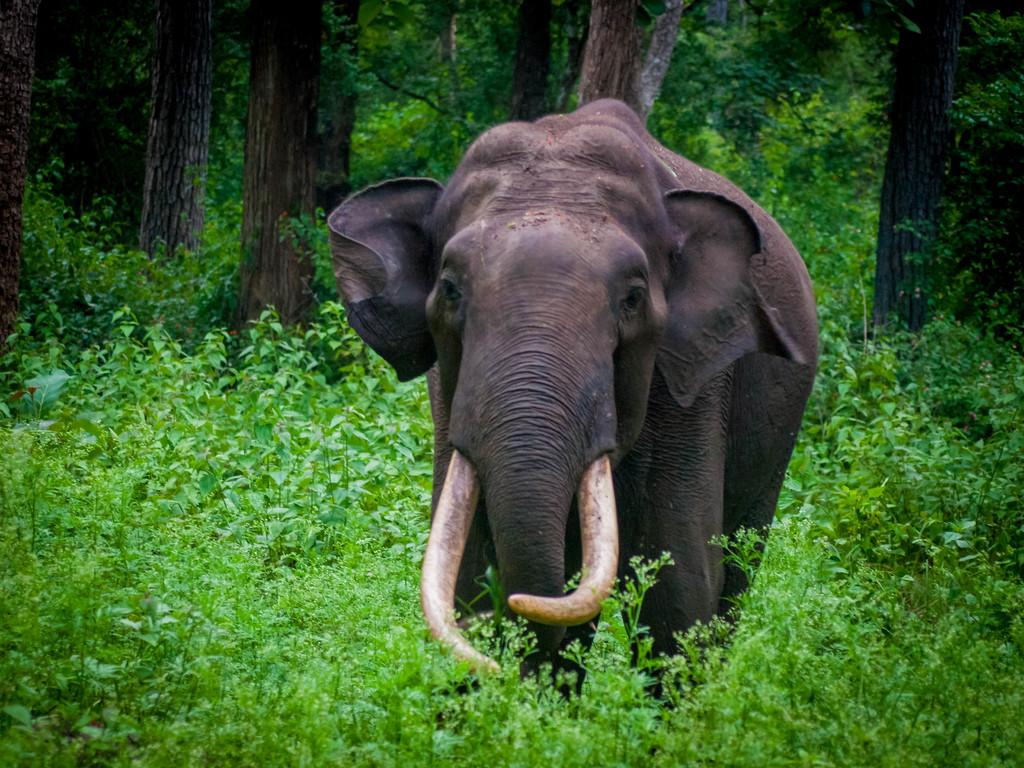What type of environment is depicted in the image? The image appears to depict a forest. What animal can be seen in the image? There is an elephant in the image. What color are the plants at the bottom of the image? The plants at the bottom of the image are green. What can be seen in the background of the image? There are trees in the background of the image. What type of cream is being served for dinner in the image? There is no dinner or cream present in the image; it depicts a forest with an elephant and green plants. 